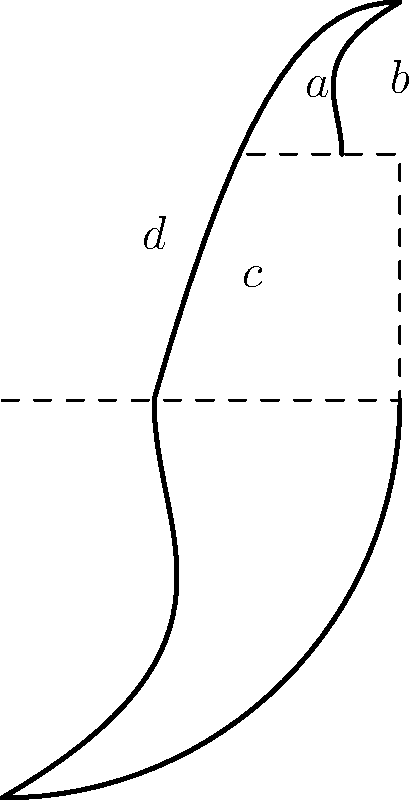The spiral diagram above illustrates the golden ratio in nature and art. If the length of the smallest arc segment is $a$, express the length of the largest arc segment in terms of $a$ and the golden ratio $\phi$. Round your answer to the nearest whole number. To solve this problem, let's follow these steps:

1) The golden ratio, $\phi$, is approximately 1.618.

2) In the spiral, each segment is $\phi$ times longer than the previous one.

3) Starting with the smallest segment $a$, we can express the lengths of the subsequent segments:
   - Second segment: $b = a \cdot \phi$
   - Third segment: $c = b \cdot \phi = a \cdot \phi^2$
   - Fourth (largest) segment: $d = c \cdot \phi = a \cdot \phi^3$

4) Let's calculate $\phi^3$:
   $\phi^3 \approx 1.618^3 \approx 4.236$

5) Therefore, the length of the largest segment is approximately $4.236a$.

6) Rounding to the nearest whole number: $4.236 \approx 4$

Thus, the length of the largest arc segment can be expressed as approximately $4a$.
Answer: $4a$ 